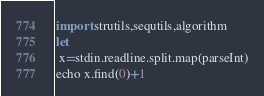Convert code to text. <code><loc_0><loc_0><loc_500><loc_500><_Nim_>import strutils,sequtils,algorithm
let
 x=stdin.readline.split.map(parseInt)
echo x.find(0)+1</code> 